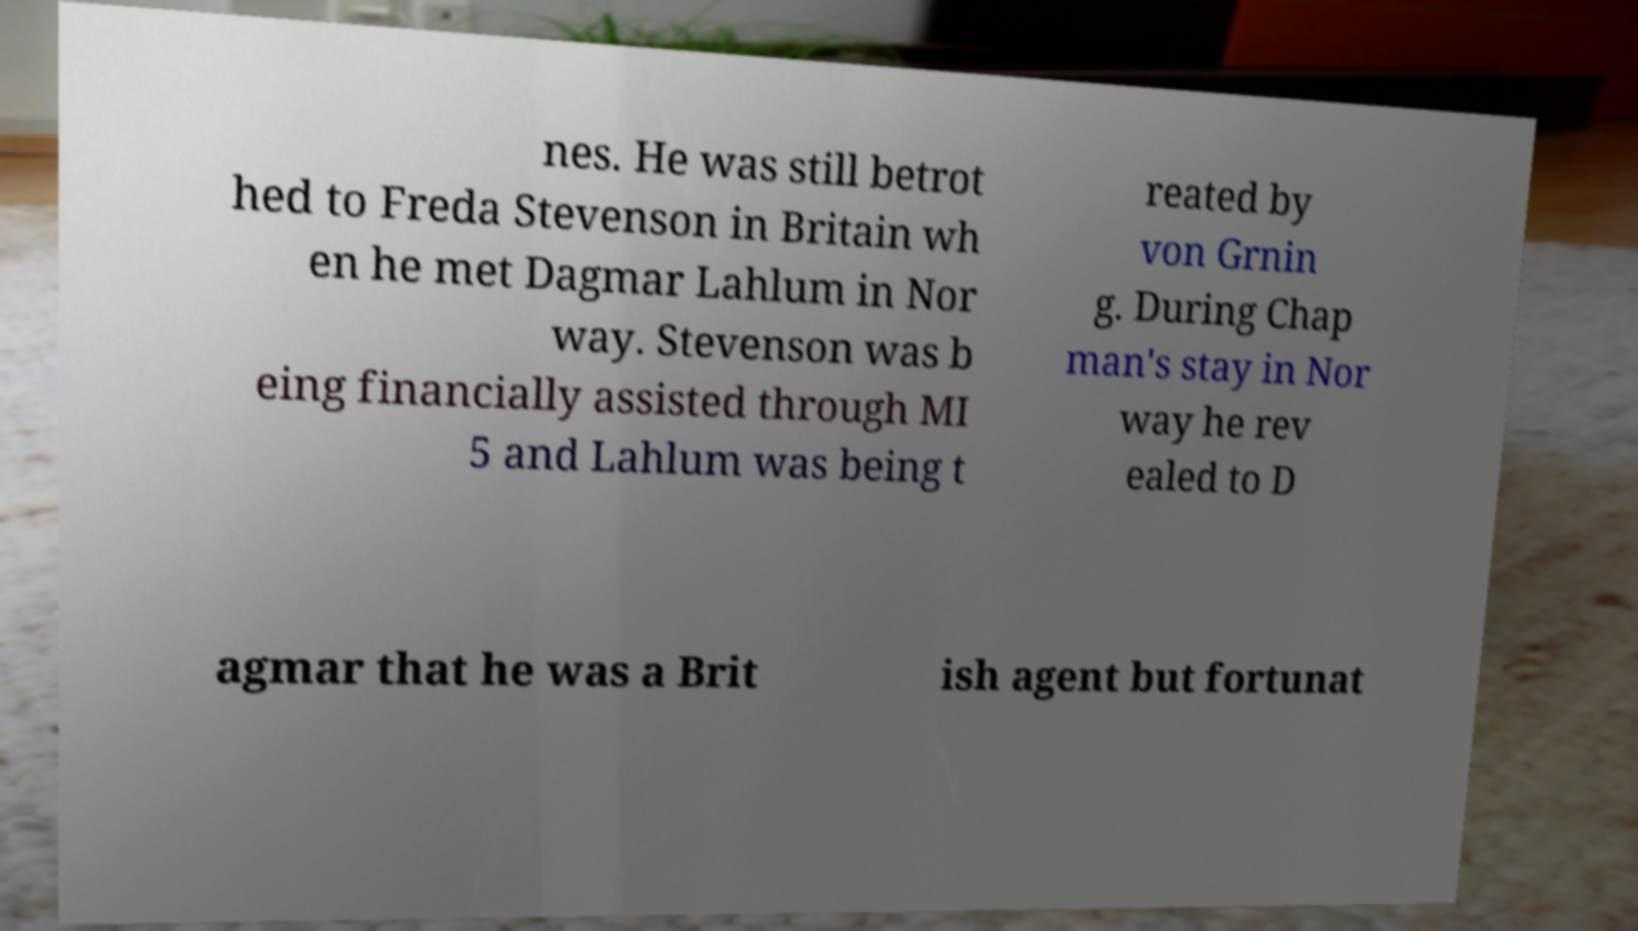Can you accurately transcribe the text from the provided image for me? nes. He was still betrot hed to Freda Stevenson in Britain wh en he met Dagmar Lahlum in Nor way. Stevenson was b eing financially assisted through MI 5 and Lahlum was being t reated by von Grnin g. During Chap man's stay in Nor way he rev ealed to D agmar that he was a Brit ish agent but fortunat 